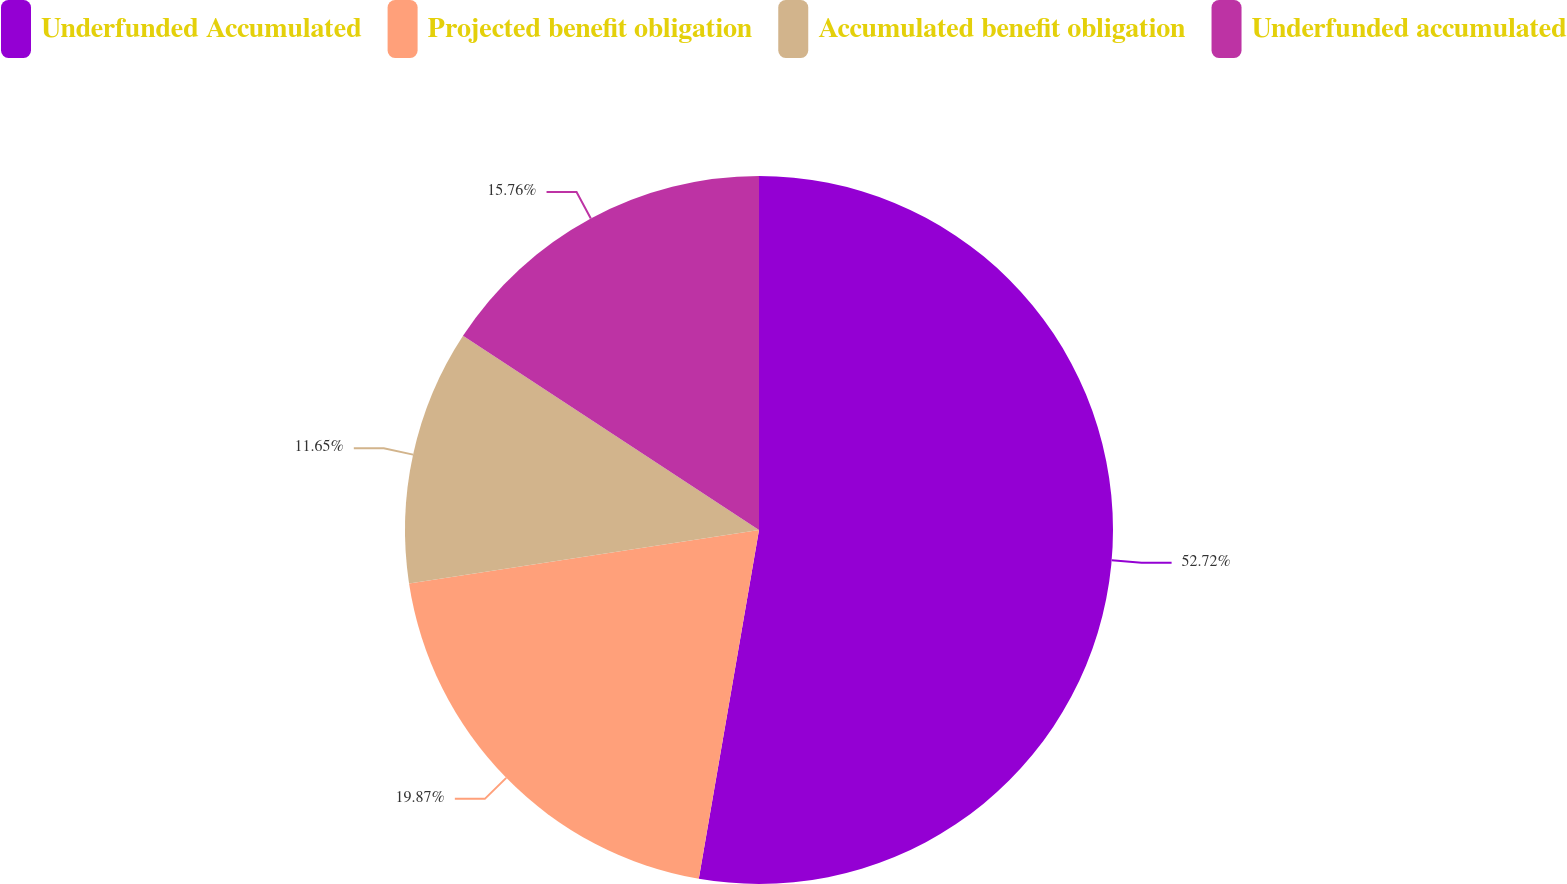Convert chart to OTSL. <chart><loc_0><loc_0><loc_500><loc_500><pie_chart><fcel>Underfunded Accumulated<fcel>Projected benefit obligation<fcel>Accumulated benefit obligation<fcel>Underfunded accumulated<nl><fcel>52.72%<fcel>19.87%<fcel>11.65%<fcel>15.76%<nl></chart> 